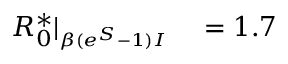Convert formula to latex. <formula><loc_0><loc_0><loc_500><loc_500>\begin{array} { r l } { R _ { 0 } ^ { * } | _ { \substack { _ { \beta ( e ^ { S } - 1 ) I } } } } & = 1 . 7 } \end{array}</formula> 